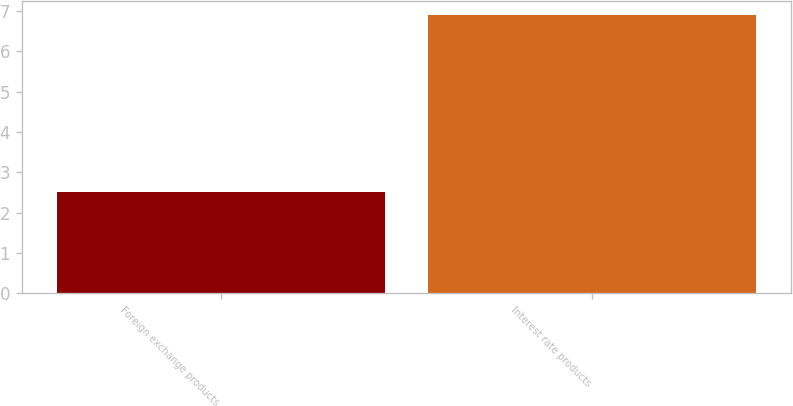<chart> <loc_0><loc_0><loc_500><loc_500><bar_chart><fcel>Foreign exchange products<fcel>Interest rate products<nl><fcel>2.5<fcel>6.9<nl></chart> 